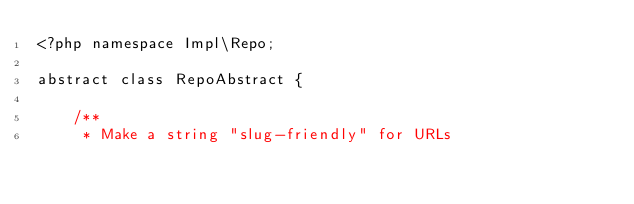Convert code to text. <code><loc_0><loc_0><loc_500><loc_500><_PHP_><?php namespace Impl\Repo;

abstract class RepoAbstract {

    /**
     * Make a string "slug-friendly" for URLs</code> 